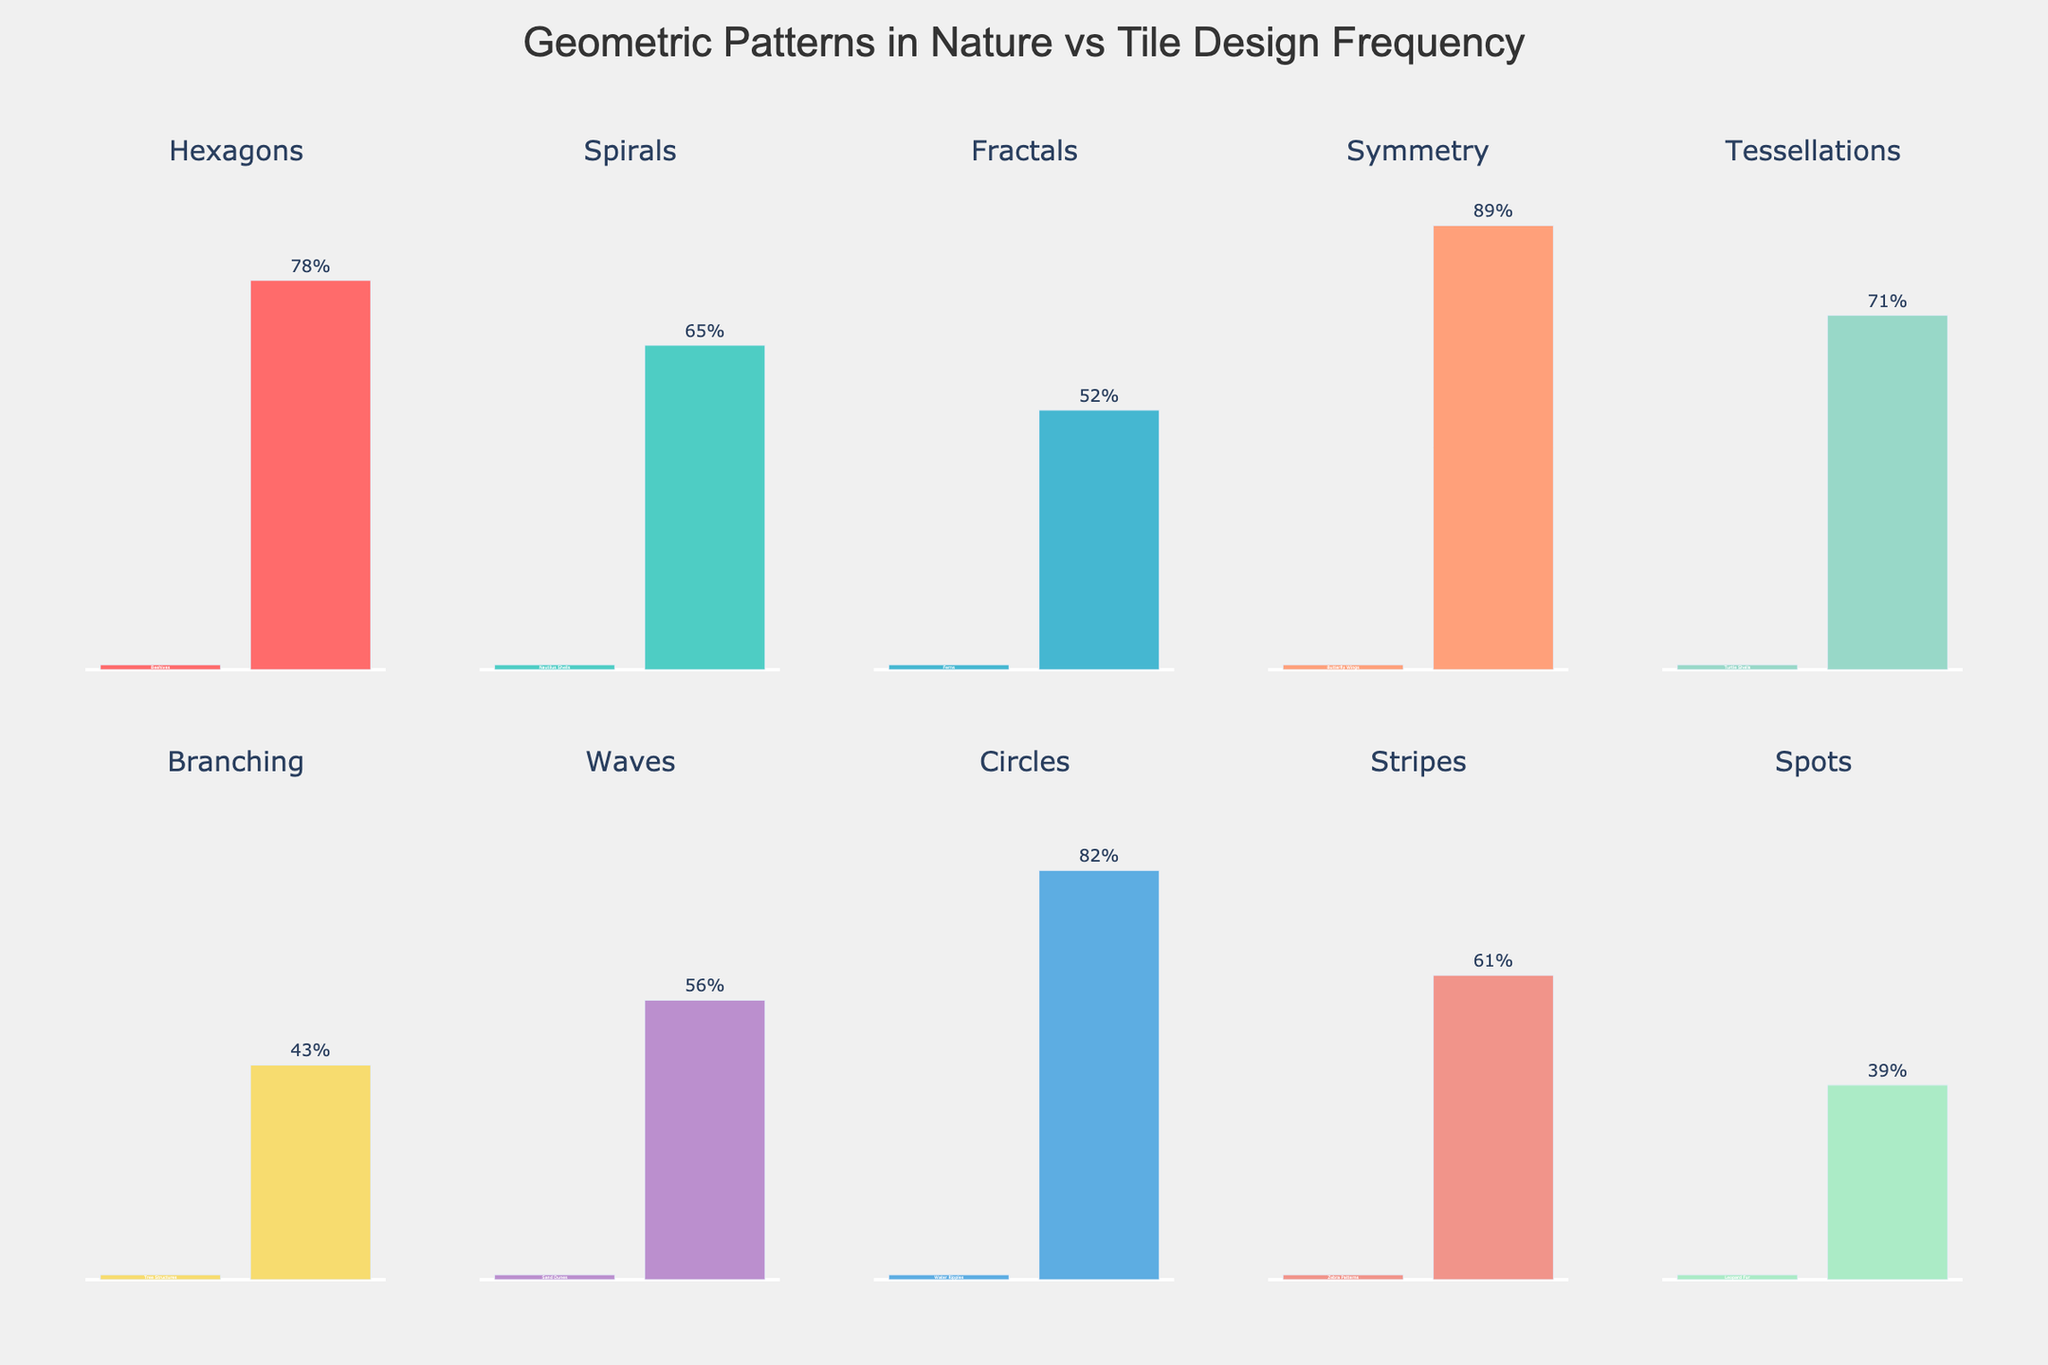Which pattern has the highest Tile Design Frequency? Observe the bar with the highest value in the Tile Design Frequency bars. The Symmetry pattern has the highest value of 89%.
Answer: Symmetry Which pattern has the lowest Tile Design Frequency? Look for the bar with the smallest value in the Tile Design Frequency bars. The pattern with Leopard Fur (Spots) has the lowest frequency of 39%.
Answer: Spots What is the sum of the Tile Design Frequencies for Hexagons and Spirals? Add the frequencies of the Tile Design bars for Hexagons (78) and Spirals (65). 78 + 65 = 143.
Answer: 143 Compare the Tile Design Frequencies between Fractals and Tessellations. Which is greater? Compare the bar heights for Fractals (52) and Tessellations (71). Tessellations have a higher frequency.
Answer: Tessellations What is the average Tile Design Frequency for all patterns? Add all the Tile Design Frequency values and divide by the number of patterns (10). (78 + 65 + 52 + 89 + 71 + 43 + 56 + 82 + 61 + 39) / 10 = 63.6.
Answer: 63.6 Between Stripes and Circles, which pattern is more commonly found in tile designs? Compare the Tile Design Frequency bars for Stripes (61) and Circles (82). Circles have a higher frequency.
Answer: Circles Which natural occurrence has a corresponding Tile Design Frequency that matches its Visual Natural Occurrence color bar? Observe the bars with matching heights for both categories. All bars have different values, so there is no matching pair.
Answer: None What is the difference in Tile Design Frequencies between Symmetry and Fractals? Subtract the Tile Design Frequency of Fractals (52) from that of Symmetry (89). 89 - 52 = 37.
Answer: 37 What is the median Tile Design Frequency of all patterns? Arrange the frequencies in order (39, 43, 52, 56, 61, 65, 71, 78, 82, 89), and find the middle value. For 10 values, the median is the average of the 5th and 6th values, (65 + 61) / 2 = 63.
Answer: 63 